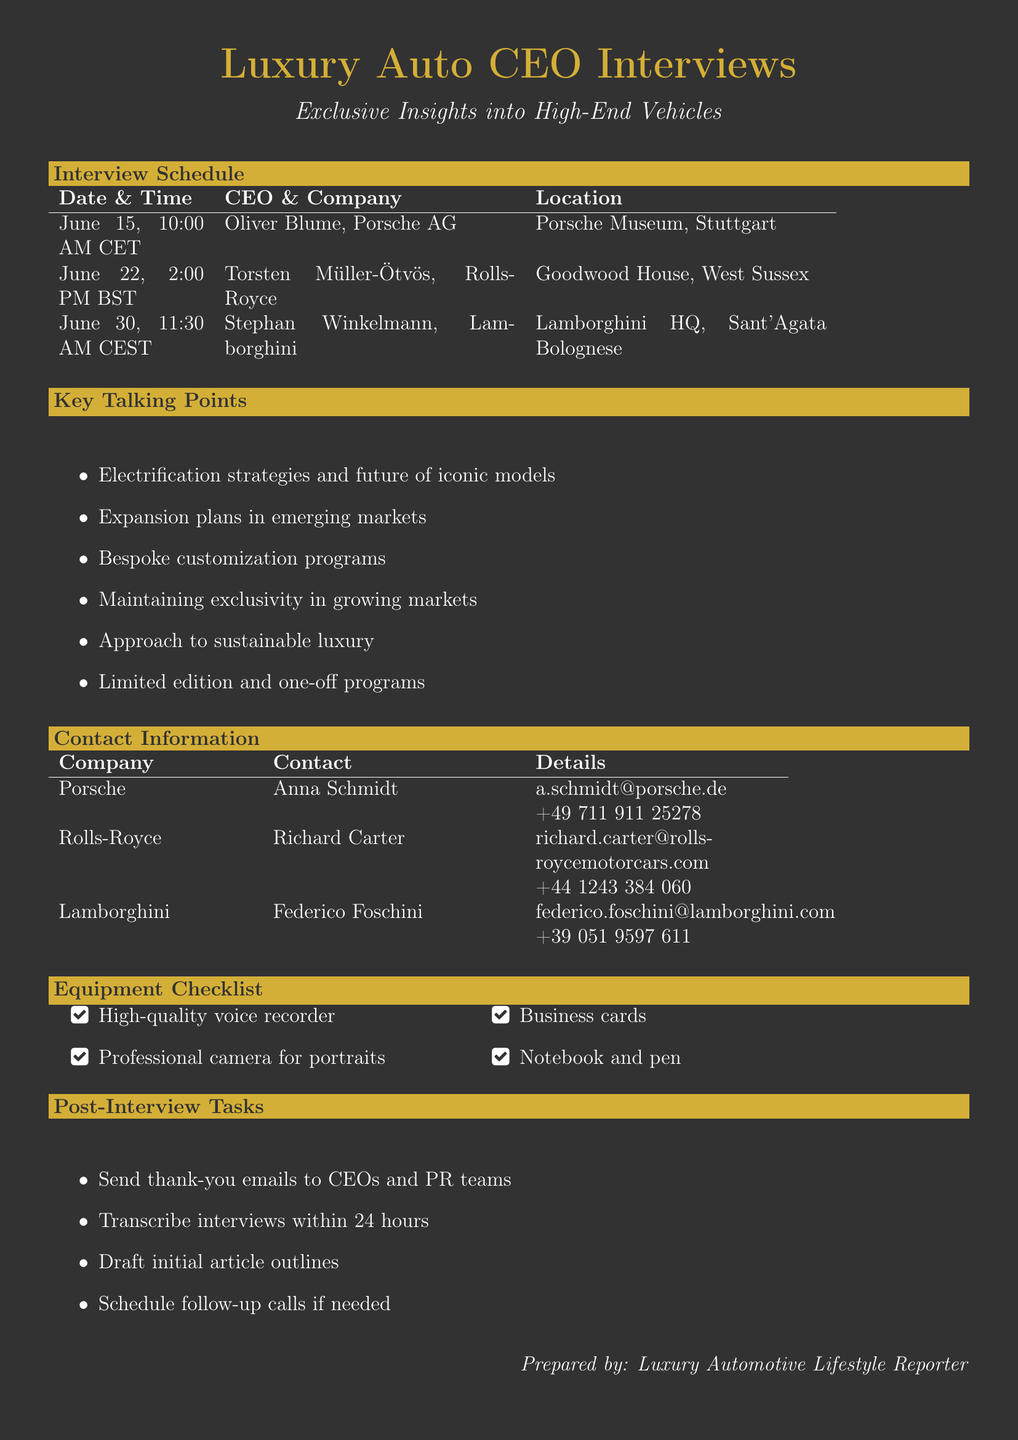What is the date of the interview with Oliver Blume? The date of the interview with Oliver Blume is specified in the document under the interview schedule section.
Answer: June 15 What is the location of the Rolls-Royce interview? The location of the Rolls-Royce interview is mentioned alongside the date in the interview schedule.
Answer: Goodwood House, West Sussex Who is the contact person for Lamborghini? The contact person for Lamborghini is listed in the contact information section of the document.
Answer: Federico Foschini What is one of the key talking points for Porsche? Key talking points are provided in a bulleted list, detailing subjects for discussion with Porsche.
Answer: Porsche's electrification strategy What is the time of the interview with Torsten Müller-Ötvös? The time for Torsten Müller-Ötvös's interview is located in the interview schedule section.
Answer: 2:00 PM BST What is included in the equipment checklist? The checklist outlines necessary equipment and is a specific section of the document.
Answer: High-quality voice recorder What is a post-interview task? Post-interview tasks are listed as follow-up actions the reporter needs to perform after the interviews.
Answer: Send thank-you emails to CEOs and PR teams How many luxury car brands are scheduled for interviews in this memo? The number of interviews scheduled can be counted from the interview schedule section provided in the document.
Answer: Three What is a key topic for Rolls-Royce? Key topics for discussion are detailed under each brand's talking points in the document.
Answer: Rolls-Royce's first all-electric car: Spectre 